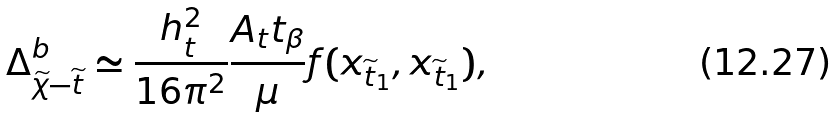Convert formula to latex. <formula><loc_0><loc_0><loc_500><loc_500>\Delta _ { \widetilde { \chi } - \widetilde { t } } ^ { b } \simeq \frac { h _ { t } ^ { 2 } } { 1 6 \pi ^ { 2 } } \frac { A _ { t } t _ { \beta } } { \mu } f ( x _ { \widetilde { t } _ { 1 } } , x _ { \widetilde { t } _ { 1 } } ) ,</formula> 